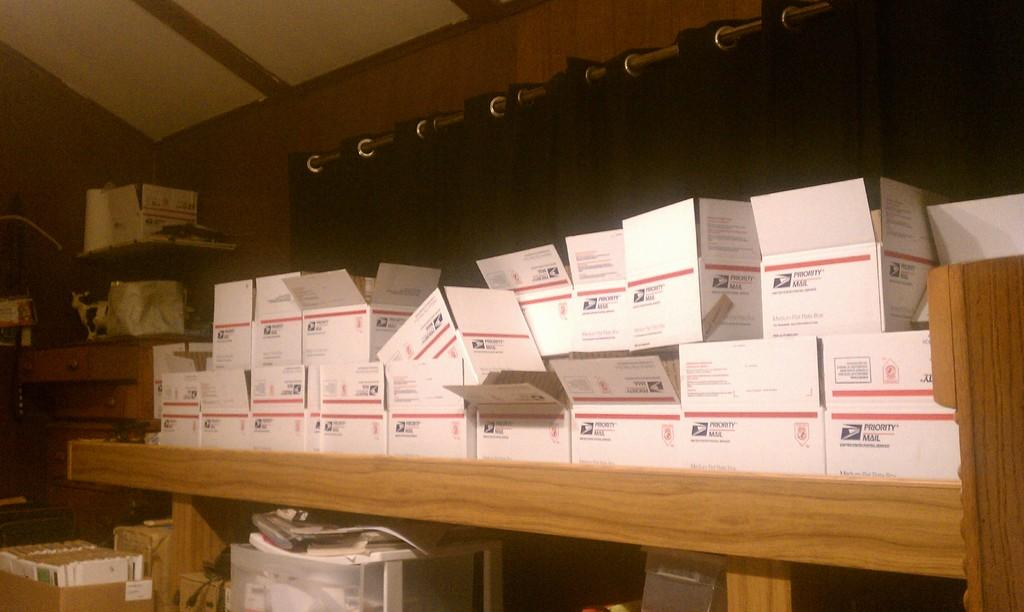What can be seen in the racks in the image? There are boxes in the racks in the image. What is located in the background of the image? There is a metal rod and a curtain in the background of the image. Can you see a squirrel wearing a veil in the image? No, there is no squirrel or veil present in the image. What causes the burst of colors in the image? There is no burst of colors in the image; the colors are consistent and muted. 